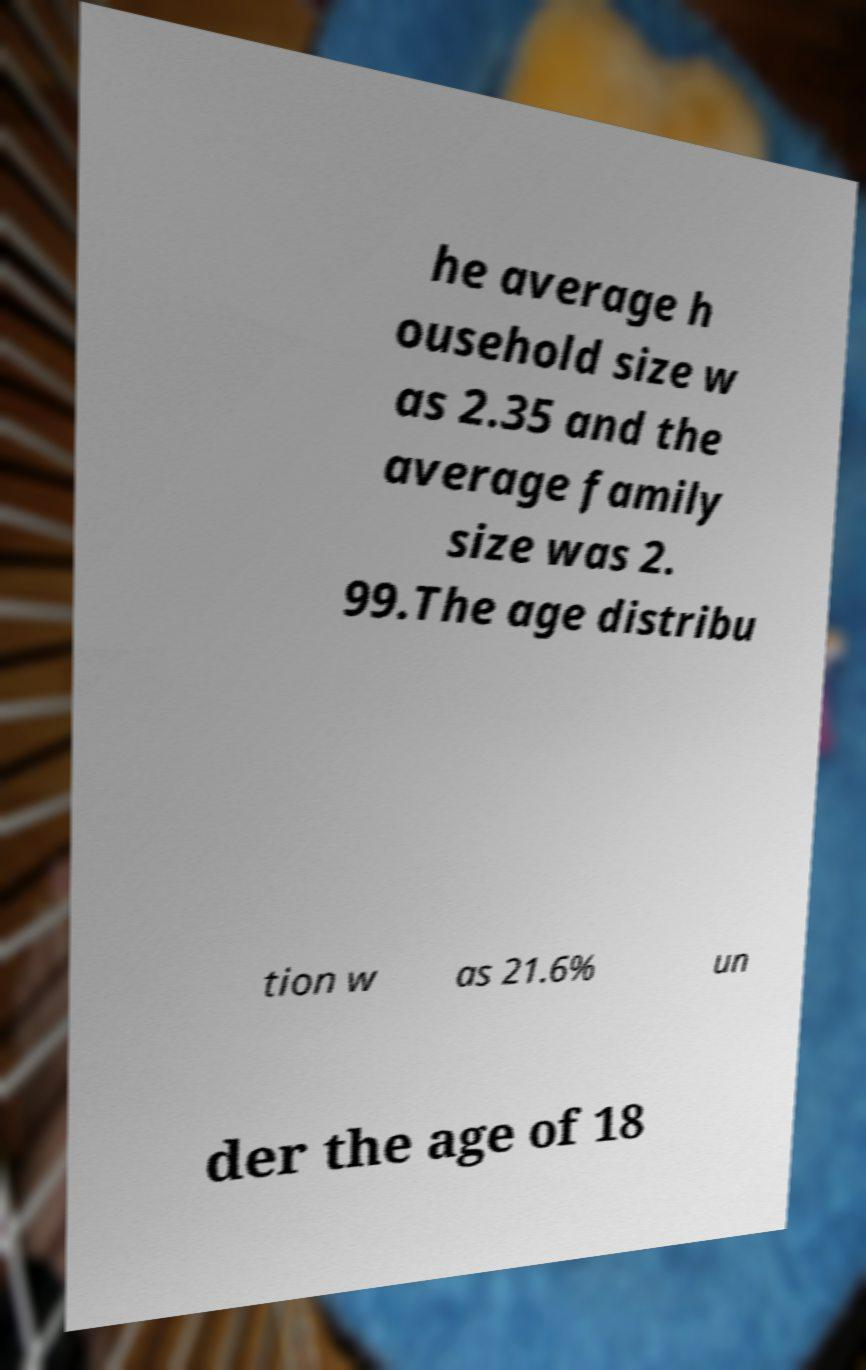For documentation purposes, I need the text within this image transcribed. Could you provide that? he average h ousehold size w as 2.35 and the average family size was 2. 99.The age distribu tion w as 21.6% un der the age of 18 